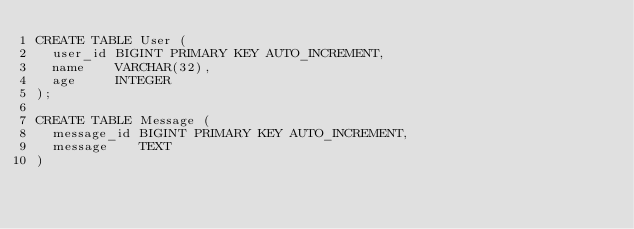<code> <loc_0><loc_0><loc_500><loc_500><_SQL_>CREATE TABLE User (
  user_id BIGINT PRIMARY KEY AUTO_INCREMENT,
  name    VARCHAR(32),
  age     INTEGER
);

CREATE TABLE Message (
  message_id BIGINT PRIMARY KEY AUTO_INCREMENT,
  message    TEXT
)</code> 